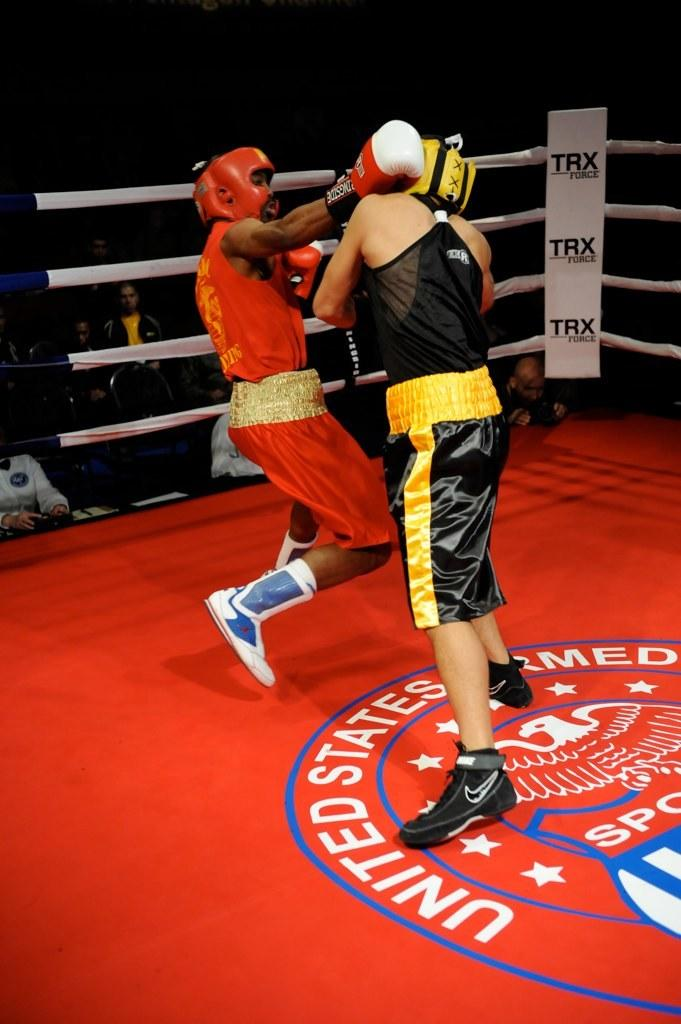<image>
Write a terse but informative summary of the picture. Two men boxing in a US Armed Forces ring with TRX in the corners. 